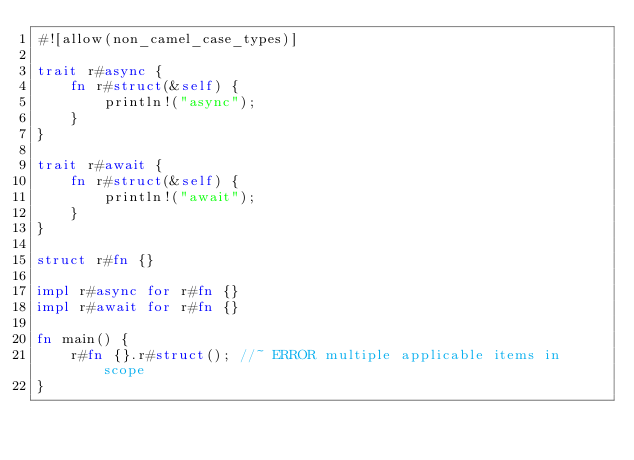Convert code to text. <code><loc_0><loc_0><loc_500><loc_500><_Rust_>#![allow(non_camel_case_types)]

trait r#async {
    fn r#struct(&self) {
        println!("async");
    }
}

trait r#await {
    fn r#struct(&self) {
        println!("await");
    }
}

struct r#fn {}

impl r#async for r#fn {}
impl r#await for r#fn {}

fn main() {
    r#fn {}.r#struct(); //~ ERROR multiple applicable items in scope
}
</code> 